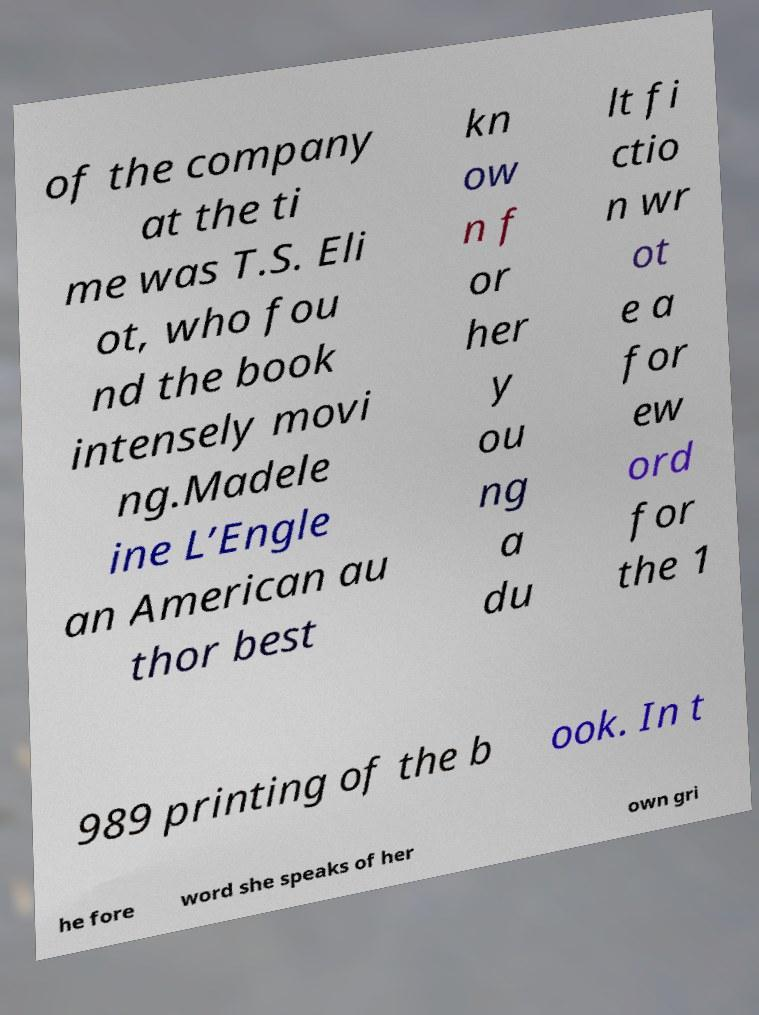For documentation purposes, I need the text within this image transcribed. Could you provide that? of the company at the ti me was T.S. Eli ot, who fou nd the book intensely movi ng.Madele ine L’Engle an American au thor best kn ow n f or her y ou ng a du lt fi ctio n wr ot e a for ew ord for the 1 989 printing of the b ook. In t he fore word she speaks of her own gri 